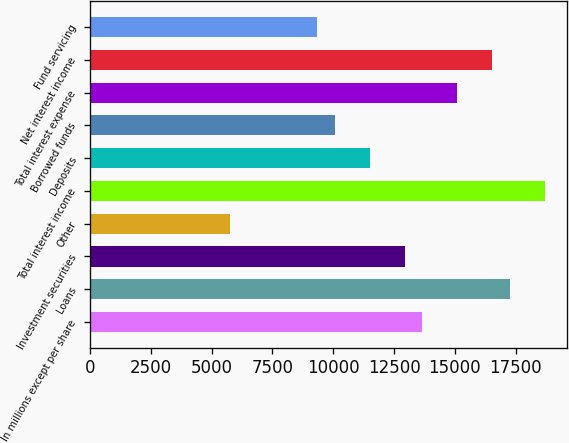<chart> <loc_0><loc_0><loc_500><loc_500><bar_chart><fcel>In millions except per share<fcel>Loans<fcel>Investment securities<fcel>Other<fcel>Total interest income<fcel>Deposits<fcel>Borrowed funds<fcel>Total interest expense<fcel>Net interest income<fcel>Fund servicing<nl><fcel>13658.7<fcel>17252.5<fcel>12940<fcel>5752.46<fcel>18690<fcel>11502.5<fcel>10065<fcel>15096.2<fcel>16533.7<fcel>9346.21<nl></chart> 